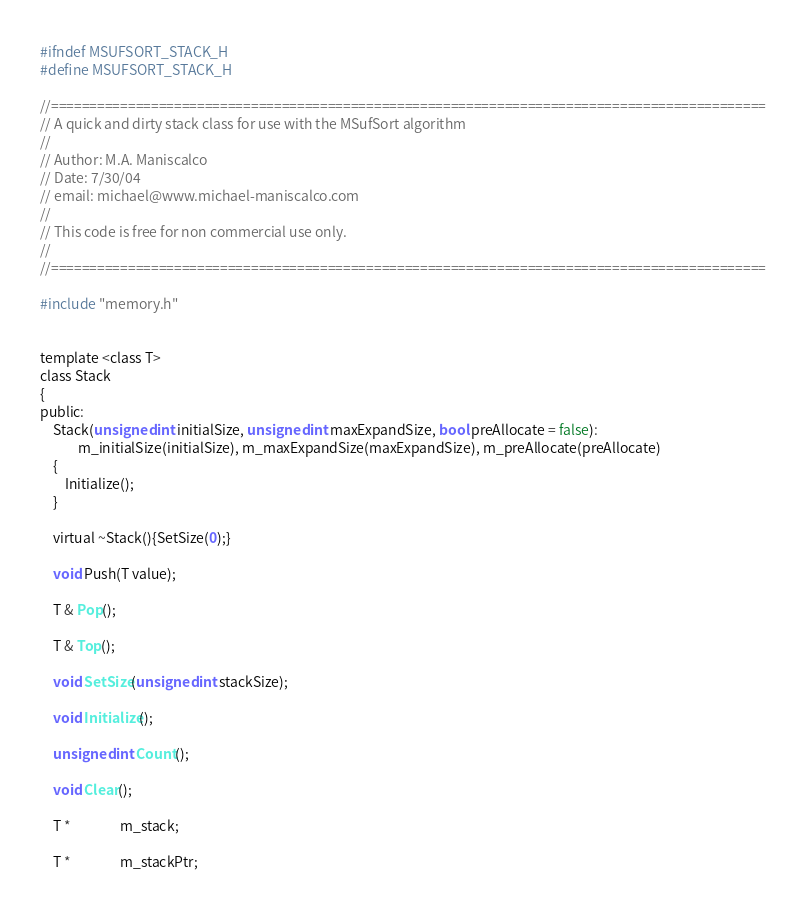Convert code to text. <code><loc_0><loc_0><loc_500><loc_500><_C_>#ifndef MSUFSORT_STACK_H
#define MSUFSORT_STACK_H

//=============================================================================================
// A quick and dirty stack class for use with the MSufSort algorithm
//
// Author: M.A. Maniscalco
// Date: 7/30/04
// email: michael@www.michael-maniscalco.com
//
// This code is free for non commercial use only.
//
//=============================================================================================

#include "memory.h"


template <class T>
class Stack 
{
public:
	Stack(unsigned int initialSize, unsigned int maxExpandSize, bool preAllocate = false):
			m_initialSize(initialSize), m_maxExpandSize(maxExpandSize), m_preAllocate(preAllocate)
	{
		Initialize();
	}

	virtual ~Stack(){SetSize(0);}

	void Push(T value);

	T & Pop();

	T & Top();

	void SetSize(unsigned int stackSize);

	void Initialize();

	unsigned int Count();

	void Clear();

	T *				m_stack;

	T *				m_stackPtr;
</code> 